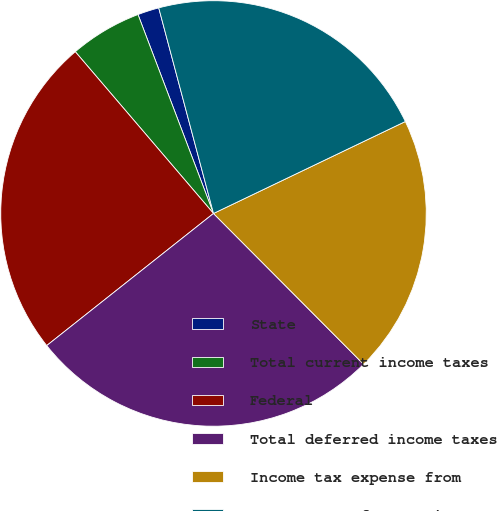Convert chart to OTSL. <chart><loc_0><loc_0><loc_500><loc_500><pie_chart><fcel>State<fcel>Total current income taxes<fcel>Federal<fcel>Total deferred income taxes<fcel>Income tax expense from<fcel>Statements of Operations<nl><fcel>1.63%<fcel>5.48%<fcel>24.41%<fcel>26.8%<fcel>19.65%<fcel>22.03%<nl></chart> 